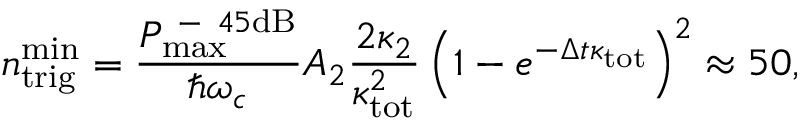<formula> <loc_0><loc_0><loc_500><loc_500>n _ { t r i g } ^ { \min } = \frac { P _ { \max } ^ { - 4 5 d B } } { \hbar { \omega } _ { c } } A _ { 2 } \frac { 2 \kappa _ { 2 } } { \kappa _ { t o t } ^ { 2 } } \left ( 1 - e ^ { - \Delta t \kappa _ { t o t } } \right ) ^ { 2 } \approx 5 0 ,</formula> 